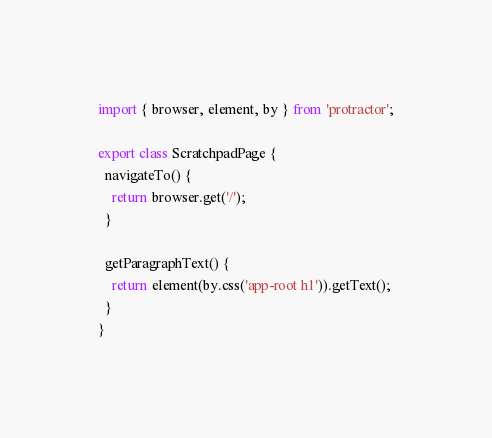Convert code to text. <code><loc_0><loc_0><loc_500><loc_500><_TypeScript_>import { browser, element, by } from 'protractor';

export class ScratchpadPage {
  navigateTo() {
    return browser.get('/');
  }

  getParagraphText() {
    return element(by.css('app-root h1')).getText();
  }
}
</code> 